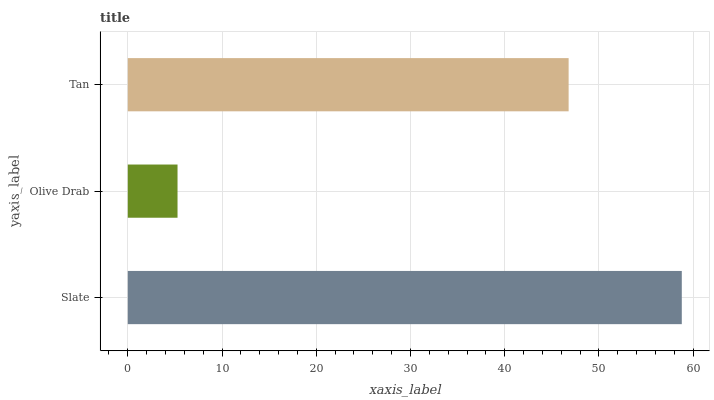Is Olive Drab the minimum?
Answer yes or no. Yes. Is Slate the maximum?
Answer yes or no. Yes. Is Tan the minimum?
Answer yes or no. No. Is Tan the maximum?
Answer yes or no. No. Is Tan greater than Olive Drab?
Answer yes or no. Yes. Is Olive Drab less than Tan?
Answer yes or no. Yes. Is Olive Drab greater than Tan?
Answer yes or no. No. Is Tan less than Olive Drab?
Answer yes or no. No. Is Tan the high median?
Answer yes or no. Yes. Is Tan the low median?
Answer yes or no. Yes. Is Olive Drab the high median?
Answer yes or no. No. Is Slate the low median?
Answer yes or no. No. 